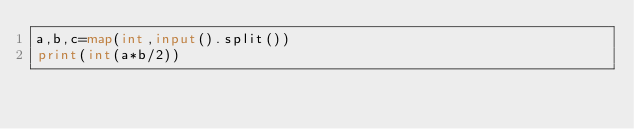Convert code to text. <code><loc_0><loc_0><loc_500><loc_500><_Python_>a,b,c=map(int,input().split())
print(int(a*b/2))</code> 